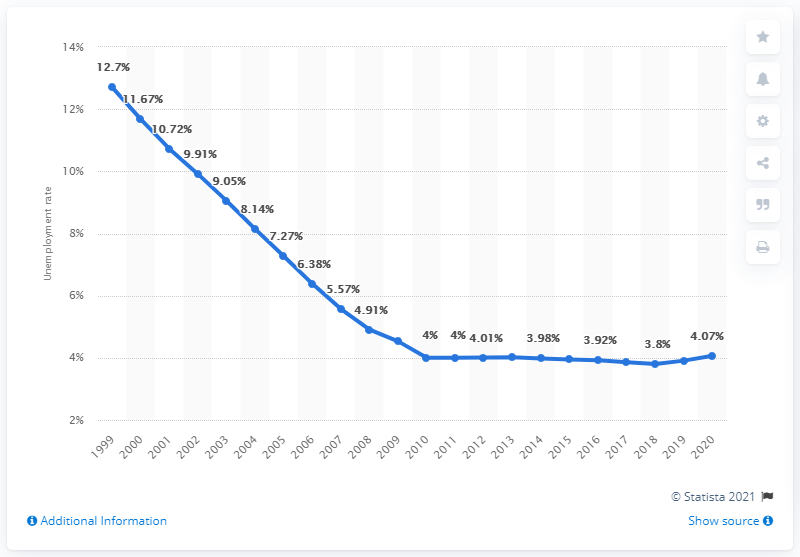Outline some significant characteristics in this image. In 2020, the unemployment rate in Turkmenistan was 4.07%. 